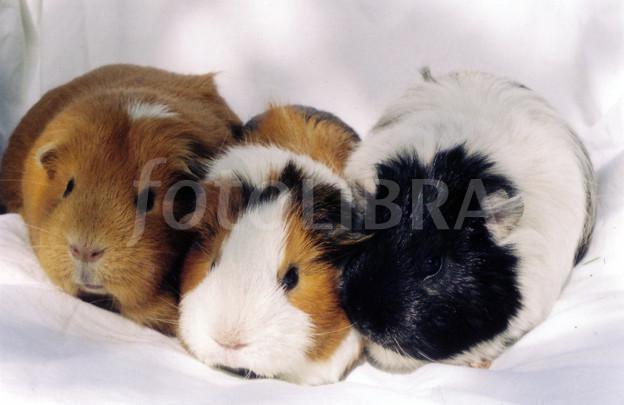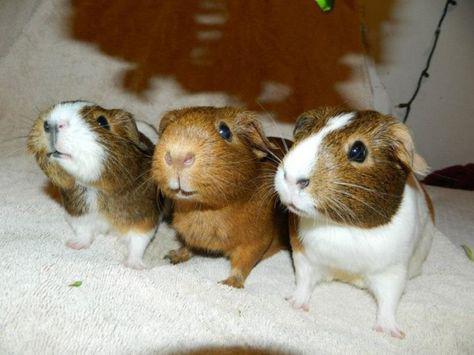The first image is the image on the left, the second image is the image on the right. For the images shown, is this caption "Each image shows exactly three guinea pigs posed tightly together side-by-side." true? Answer yes or no. Yes. The first image is the image on the left, the second image is the image on the right. For the images displayed, is the sentence "There are six mammals huddled in groups of three." factually correct? Answer yes or no. Yes. 